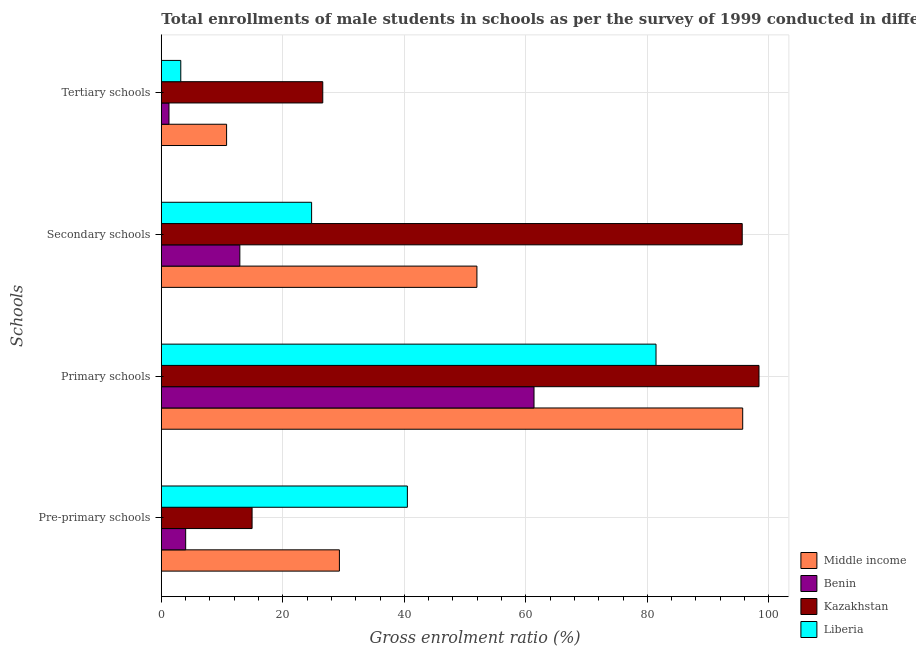How many groups of bars are there?
Give a very brief answer. 4. Are the number of bars on each tick of the Y-axis equal?
Provide a succinct answer. Yes. How many bars are there on the 1st tick from the bottom?
Your response must be concise. 4. What is the label of the 1st group of bars from the top?
Your answer should be very brief. Tertiary schools. What is the gross enrolment ratio(male) in pre-primary schools in Middle income?
Provide a succinct answer. 29.31. Across all countries, what is the maximum gross enrolment ratio(male) in primary schools?
Provide a short and direct response. 98.38. Across all countries, what is the minimum gross enrolment ratio(male) in primary schools?
Your response must be concise. 61.35. In which country was the gross enrolment ratio(male) in pre-primary schools maximum?
Your answer should be compact. Liberia. In which country was the gross enrolment ratio(male) in tertiary schools minimum?
Keep it short and to the point. Benin. What is the total gross enrolment ratio(male) in primary schools in the graph?
Your response must be concise. 336.86. What is the difference between the gross enrolment ratio(male) in pre-primary schools in Liberia and that in Benin?
Make the answer very short. 36.49. What is the difference between the gross enrolment ratio(male) in tertiary schools in Liberia and the gross enrolment ratio(male) in primary schools in Benin?
Ensure brevity in your answer.  -58.14. What is the average gross enrolment ratio(male) in primary schools per country?
Offer a very short reply. 84.21. What is the difference between the gross enrolment ratio(male) in primary schools and gross enrolment ratio(male) in secondary schools in Kazakhstan?
Make the answer very short. 2.76. What is the ratio of the gross enrolment ratio(male) in pre-primary schools in Benin to that in Kazakhstan?
Your answer should be very brief. 0.27. Is the gross enrolment ratio(male) in pre-primary schools in Benin less than that in Liberia?
Your response must be concise. Yes. What is the difference between the highest and the second highest gross enrolment ratio(male) in secondary schools?
Your answer should be very brief. 43.67. What is the difference between the highest and the lowest gross enrolment ratio(male) in tertiary schools?
Keep it short and to the point. 25.31. In how many countries, is the gross enrolment ratio(male) in primary schools greater than the average gross enrolment ratio(male) in primary schools taken over all countries?
Keep it short and to the point. 2. What does the 3rd bar from the top in Primary schools represents?
Provide a short and direct response. Benin. What does the 4th bar from the bottom in Pre-primary schools represents?
Make the answer very short. Liberia. Is it the case that in every country, the sum of the gross enrolment ratio(male) in pre-primary schools and gross enrolment ratio(male) in primary schools is greater than the gross enrolment ratio(male) in secondary schools?
Provide a short and direct response. Yes. Does the graph contain any zero values?
Your answer should be very brief. No. How many legend labels are there?
Offer a terse response. 4. What is the title of the graph?
Keep it short and to the point. Total enrollments of male students in schools as per the survey of 1999 conducted in different countries. What is the label or title of the Y-axis?
Provide a succinct answer. Schools. What is the Gross enrolment ratio (%) of Middle income in Pre-primary schools?
Your answer should be compact. 29.31. What is the Gross enrolment ratio (%) in Benin in Pre-primary schools?
Ensure brevity in your answer.  4.01. What is the Gross enrolment ratio (%) in Kazakhstan in Pre-primary schools?
Provide a short and direct response. 14.94. What is the Gross enrolment ratio (%) in Liberia in Pre-primary schools?
Your response must be concise. 40.5. What is the Gross enrolment ratio (%) in Middle income in Primary schools?
Your answer should be compact. 95.7. What is the Gross enrolment ratio (%) in Benin in Primary schools?
Give a very brief answer. 61.35. What is the Gross enrolment ratio (%) of Kazakhstan in Primary schools?
Provide a succinct answer. 98.38. What is the Gross enrolment ratio (%) of Liberia in Primary schools?
Provide a succinct answer. 81.43. What is the Gross enrolment ratio (%) in Middle income in Secondary schools?
Make the answer very short. 51.95. What is the Gross enrolment ratio (%) in Benin in Secondary schools?
Provide a short and direct response. 12.93. What is the Gross enrolment ratio (%) of Kazakhstan in Secondary schools?
Your answer should be compact. 95.62. What is the Gross enrolment ratio (%) in Liberia in Secondary schools?
Offer a terse response. 24.74. What is the Gross enrolment ratio (%) of Middle income in Tertiary schools?
Give a very brief answer. 10.74. What is the Gross enrolment ratio (%) in Benin in Tertiary schools?
Give a very brief answer. 1.26. What is the Gross enrolment ratio (%) in Kazakhstan in Tertiary schools?
Your answer should be compact. 26.58. What is the Gross enrolment ratio (%) of Liberia in Tertiary schools?
Make the answer very short. 3.2. Across all Schools, what is the maximum Gross enrolment ratio (%) in Middle income?
Offer a very short reply. 95.7. Across all Schools, what is the maximum Gross enrolment ratio (%) in Benin?
Your response must be concise. 61.35. Across all Schools, what is the maximum Gross enrolment ratio (%) in Kazakhstan?
Your response must be concise. 98.38. Across all Schools, what is the maximum Gross enrolment ratio (%) of Liberia?
Make the answer very short. 81.43. Across all Schools, what is the minimum Gross enrolment ratio (%) of Middle income?
Your response must be concise. 10.74. Across all Schools, what is the minimum Gross enrolment ratio (%) of Benin?
Provide a succinct answer. 1.26. Across all Schools, what is the minimum Gross enrolment ratio (%) in Kazakhstan?
Ensure brevity in your answer.  14.94. Across all Schools, what is the minimum Gross enrolment ratio (%) of Liberia?
Your answer should be very brief. 3.2. What is the total Gross enrolment ratio (%) of Middle income in the graph?
Provide a succinct answer. 187.71. What is the total Gross enrolment ratio (%) in Benin in the graph?
Provide a short and direct response. 79.54. What is the total Gross enrolment ratio (%) in Kazakhstan in the graph?
Your answer should be very brief. 235.52. What is the total Gross enrolment ratio (%) in Liberia in the graph?
Provide a succinct answer. 149.87. What is the difference between the Gross enrolment ratio (%) of Middle income in Pre-primary schools and that in Primary schools?
Your response must be concise. -66.39. What is the difference between the Gross enrolment ratio (%) of Benin in Pre-primary schools and that in Primary schools?
Provide a succinct answer. -57.34. What is the difference between the Gross enrolment ratio (%) in Kazakhstan in Pre-primary schools and that in Primary schools?
Make the answer very short. -83.44. What is the difference between the Gross enrolment ratio (%) of Liberia in Pre-primary schools and that in Primary schools?
Your answer should be compact. -40.93. What is the difference between the Gross enrolment ratio (%) in Middle income in Pre-primary schools and that in Secondary schools?
Offer a very short reply. -22.64. What is the difference between the Gross enrolment ratio (%) in Benin in Pre-primary schools and that in Secondary schools?
Offer a terse response. -8.92. What is the difference between the Gross enrolment ratio (%) in Kazakhstan in Pre-primary schools and that in Secondary schools?
Your response must be concise. -80.68. What is the difference between the Gross enrolment ratio (%) in Liberia in Pre-primary schools and that in Secondary schools?
Keep it short and to the point. 15.76. What is the difference between the Gross enrolment ratio (%) of Middle income in Pre-primary schools and that in Tertiary schools?
Your answer should be very brief. 18.57. What is the difference between the Gross enrolment ratio (%) of Benin in Pre-primary schools and that in Tertiary schools?
Your answer should be compact. 2.75. What is the difference between the Gross enrolment ratio (%) of Kazakhstan in Pre-primary schools and that in Tertiary schools?
Offer a terse response. -11.63. What is the difference between the Gross enrolment ratio (%) of Liberia in Pre-primary schools and that in Tertiary schools?
Keep it short and to the point. 37.3. What is the difference between the Gross enrolment ratio (%) in Middle income in Primary schools and that in Secondary schools?
Ensure brevity in your answer.  43.75. What is the difference between the Gross enrolment ratio (%) of Benin in Primary schools and that in Secondary schools?
Offer a terse response. 48.42. What is the difference between the Gross enrolment ratio (%) in Kazakhstan in Primary schools and that in Secondary schools?
Ensure brevity in your answer.  2.76. What is the difference between the Gross enrolment ratio (%) of Liberia in Primary schools and that in Secondary schools?
Give a very brief answer. 56.69. What is the difference between the Gross enrolment ratio (%) in Middle income in Primary schools and that in Tertiary schools?
Make the answer very short. 84.95. What is the difference between the Gross enrolment ratio (%) in Benin in Primary schools and that in Tertiary schools?
Give a very brief answer. 60.09. What is the difference between the Gross enrolment ratio (%) of Kazakhstan in Primary schools and that in Tertiary schools?
Your answer should be very brief. 71.81. What is the difference between the Gross enrolment ratio (%) in Liberia in Primary schools and that in Tertiary schools?
Offer a terse response. 78.23. What is the difference between the Gross enrolment ratio (%) of Middle income in Secondary schools and that in Tertiary schools?
Keep it short and to the point. 41.21. What is the difference between the Gross enrolment ratio (%) in Benin in Secondary schools and that in Tertiary schools?
Make the answer very short. 11.66. What is the difference between the Gross enrolment ratio (%) of Kazakhstan in Secondary schools and that in Tertiary schools?
Offer a very short reply. 69.05. What is the difference between the Gross enrolment ratio (%) of Liberia in Secondary schools and that in Tertiary schools?
Provide a succinct answer. 21.53. What is the difference between the Gross enrolment ratio (%) in Middle income in Pre-primary schools and the Gross enrolment ratio (%) in Benin in Primary schools?
Offer a very short reply. -32.03. What is the difference between the Gross enrolment ratio (%) of Middle income in Pre-primary schools and the Gross enrolment ratio (%) of Kazakhstan in Primary schools?
Provide a short and direct response. -69.07. What is the difference between the Gross enrolment ratio (%) in Middle income in Pre-primary schools and the Gross enrolment ratio (%) in Liberia in Primary schools?
Your answer should be very brief. -52.12. What is the difference between the Gross enrolment ratio (%) in Benin in Pre-primary schools and the Gross enrolment ratio (%) in Kazakhstan in Primary schools?
Provide a succinct answer. -94.37. What is the difference between the Gross enrolment ratio (%) of Benin in Pre-primary schools and the Gross enrolment ratio (%) of Liberia in Primary schools?
Your answer should be very brief. -77.42. What is the difference between the Gross enrolment ratio (%) of Kazakhstan in Pre-primary schools and the Gross enrolment ratio (%) of Liberia in Primary schools?
Provide a short and direct response. -66.49. What is the difference between the Gross enrolment ratio (%) of Middle income in Pre-primary schools and the Gross enrolment ratio (%) of Benin in Secondary schools?
Make the answer very short. 16.39. What is the difference between the Gross enrolment ratio (%) of Middle income in Pre-primary schools and the Gross enrolment ratio (%) of Kazakhstan in Secondary schools?
Offer a terse response. -66.31. What is the difference between the Gross enrolment ratio (%) in Middle income in Pre-primary schools and the Gross enrolment ratio (%) in Liberia in Secondary schools?
Offer a very short reply. 4.58. What is the difference between the Gross enrolment ratio (%) in Benin in Pre-primary schools and the Gross enrolment ratio (%) in Kazakhstan in Secondary schools?
Provide a succinct answer. -91.61. What is the difference between the Gross enrolment ratio (%) in Benin in Pre-primary schools and the Gross enrolment ratio (%) in Liberia in Secondary schools?
Your answer should be very brief. -20.73. What is the difference between the Gross enrolment ratio (%) in Kazakhstan in Pre-primary schools and the Gross enrolment ratio (%) in Liberia in Secondary schools?
Give a very brief answer. -9.8. What is the difference between the Gross enrolment ratio (%) of Middle income in Pre-primary schools and the Gross enrolment ratio (%) of Benin in Tertiary schools?
Your answer should be very brief. 28.05. What is the difference between the Gross enrolment ratio (%) in Middle income in Pre-primary schools and the Gross enrolment ratio (%) in Kazakhstan in Tertiary schools?
Keep it short and to the point. 2.74. What is the difference between the Gross enrolment ratio (%) of Middle income in Pre-primary schools and the Gross enrolment ratio (%) of Liberia in Tertiary schools?
Ensure brevity in your answer.  26.11. What is the difference between the Gross enrolment ratio (%) in Benin in Pre-primary schools and the Gross enrolment ratio (%) in Kazakhstan in Tertiary schools?
Provide a succinct answer. -22.57. What is the difference between the Gross enrolment ratio (%) of Benin in Pre-primary schools and the Gross enrolment ratio (%) of Liberia in Tertiary schools?
Provide a succinct answer. 0.8. What is the difference between the Gross enrolment ratio (%) of Kazakhstan in Pre-primary schools and the Gross enrolment ratio (%) of Liberia in Tertiary schools?
Offer a very short reply. 11.74. What is the difference between the Gross enrolment ratio (%) of Middle income in Primary schools and the Gross enrolment ratio (%) of Benin in Secondary schools?
Your response must be concise. 82.77. What is the difference between the Gross enrolment ratio (%) of Middle income in Primary schools and the Gross enrolment ratio (%) of Kazakhstan in Secondary schools?
Keep it short and to the point. 0.08. What is the difference between the Gross enrolment ratio (%) in Middle income in Primary schools and the Gross enrolment ratio (%) in Liberia in Secondary schools?
Offer a very short reply. 70.96. What is the difference between the Gross enrolment ratio (%) of Benin in Primary schools and the Gross enrolment ratio (%) of Kazakhstan in Secondary schools?
Keep it short and to the point. -34.27. What is the difference between the Gross enrolment ratio (%) of Benin in Primary schools and the Gross enrolment ratio (%) of Liberia in Secondary schools?
Provide a succinct answer. 36.61. What is the difference between the Gross enrolment ratio (%) of Kazakhstan in Primary schools and the Gross enrolment ratio (%) of Liberia in Secondary schools?
Provide a short and direct response. 73.64. What is the difference between the Gross enrolment ratio (%) in Middle income in Primary schools and the Gross enrolment ratio (%) in Benin in Tertiary schools?
Ensure brevity in your answer.  94.44. What is the difference between the Gross enrolment ratio (%) of Middle income in Primary schools and the Gross enrolment ratio (%) of Kazakhstan in Tertiary schools?
Keep it short and to the point. 69.12. What is the difference between the Gross enrolment ratio (%) of Middle income in Primary schools and the Gross enrolment ratio (%) of Liberia in Tertiary schools?
Make the answer very short. 92.5. What is the difference between the Gross enrolment ratio (%) in Benin in Primary schools and the Gross enrolment ratio (%) in Kazakhstan in Tertiary schools?
Your answer should be compact. 34.77. What is the difference between the Gross enrolment ratio (%) of Benin in Primary schools and the Gross enrolment ratio (%) of Liberia in Tertiary schools?
Your answer should be compact. 58.14. What is the difference between the Gross enrolment ratio (%) in Kazakhstan in Primary schools and the Gross enrolment ratio (%) in Liberia in Tertiary schools?
Keep it short and to the point. 95.18. What is the difference between the Gross enrolment ratio (%) of Middle income in Secondary schools and the Gross enrolment ratio (%) of Benin in Tertiary schools?
Offer a very short reply. 50.69. What is the difference between the Gross enrolment ratio (%) of Middle income in Secondary schools and the Gross enrolment ratio (%) of Kazakhstan in Tertiary schools?
Provide a succinct answer. 25.38. What is the difference between the Gross enrolment ratio (%) in Middle income in Secondary schools and the Gross enrolment ratio (%) in Liberia in Tertiary schools?
Your response must be concise. 48.75. What is the difference between the Gross enrolment ratio (%) of Benin in Secondary schools and the Gross enrolment ratio (%) of Kazakhstan in Tertiary schools?
Keep it short and to the point. -13.65. What is the difference between the Gross enrolment ratio (%) in Benin in Secondary schools and the Gross enrolment ratio (%) in Liberia in Tertiary schools?
Your response must be concise. 9.72. What is the difference between the Gross enrolment ratio (%) of Kazakhstan in Secondary schools and the Gross enrolment ratio (%) of Liberia in Tertiary schools?
Your answer should be compact. 92.42. What is the average Gross enrolment ratio (%) of Middle income per Schools?
Ensure brevity in your answer.  46.93. What is the average Gross enrolment ratio (%) in Benin per Schools?
Your answer should be very brief. 19.89. What is the average Gross enrolment ratio (%) of Kazakhstan per Schools?
Give a very brief answer. 58.88. What is the average Gross enrolment ratio (%) of Liberia per Schools?
Provide a succinct answer. 37.47. What is the difference between the Gross enrolment ratio (%) of Middle income and Gross enrolment ratio (%) of Benin in Pre-primary schools?
Your answer should be compact. 25.3. What is the difference between the Gross enrolment ratio (%) in Middle income and Gross enrolment ratio (%) in Kazakhstan in Pre-primary schools?
Give a very brief answer. 14.37. What is the difference between the Gross enrolment ratio (%) of Middle income and Gross enrolment ratio (%) of Liberia in Pre-primary schools?
Provide a short and direct response. -11.19. What is the difference between the Gross enrolment ratio (%) in Benin and Gross enrolment ratio (%) in Kazakhstan in Pre-primary schools?
Keep it short and to the point. -10.93. What is the difference between the Gross enrolment ratio (%) of Benin and Gross enrolment ratio (%) of Liberia in Pre-primary schools?
Your answer should be very brief. -36.49. What is the difference between the Gross enrolment ratio (%) of Kazakhstan and Gross enrolment ratio (%) of Liberia in Pre-primary schools?
Offer a terse response. -25.56. What is the difference between the Gross enrolment ratio (%) of Middle income and Gross enrolment ratio (%) of Benin in Primary schools?
Provide a short and direct response. 34.35. What is the difference between the Gross enrolment ratio (%) of Middle income and Gross enrolment ratio (%) of Kazakhstan in Primary schools?
Offer a terse response. -2.68. What is the difference between the Gross enrolment ratio (%) in Middle income and Gross enrolment ratio (%) in Liberia in Primary schools?
Offer a very short reply. 14.27. What is the difference between the Gross enrolment ratio (%) in Benin and Gross enrolment ratio (%) in Kazakhstan in Primary schools?
Make the answer very short. -37.03. What is the difference between the Gross enrolment ratio (%) in Benin and Gross enrolment ratio (%) in Liberia in Primary schools?
Offer a terse response. -20.08. What is the difference between the Gross enrolment ratio (%) of Kazakhstan and Gross enrolment ratio (%) of Liberia in Primary schools?
Make the answer very short. 16.95. What is the difference between the Gross enrolment ratio (%) of Middle income and Gross enrolment ratio (%) of Benin in Secondary schools?
Keep it short and to the point. 39.02. What is the difference between the Gross enrolment ratio (%) of Middle income and Gross enrolment ratio (%) of Kazakhstan in Secondary schools?
Your answer should be compact. -43.67. What is the difference between the Gross enrolment ratio (%) of Middle income and Gross enrolment ratio (%) of Liberia in Secondary schools?
Ensure brevity in your answer.  27.21. What is the difference between the Gross enrolment ratio (%) of Benin and Gross enrolment ratio (%) of Kazakhstan in Secondary schools?
Keep it short and to the point. -82.69. What is the difference between the Gross enrolment ratio (%) in Benin and Gross enrolment ratio (%) in Liberia in Secondary schools?
Your response must be concise. -11.81. What is the difference between the Gross enrolment ratio (%) in Kazakhstan and Gross enrolment ratio (%) in Liberia in Secondary schools?
Keep it short and to the point. 70.88. What is the difference between the Gross enrolment ratio (%) in Middle income and Gross enrolment ratio (%) in Benin in Tertiary schools?
Offer a very short reply. 9.48. What is the difference between the Gross enrolment ratio (%) in Middle income and Gross enrolment ratio (%) in Kazakhstan in Tertiary schools?
Keep it short and to the point. -15.83. What is the difference between the Gross enrolment ratio (%) of Middle income and Gross enrolment ratio (%) of Liberia in Tertiary schools?
Offer a terse response. 7.54. What is the difference between the Gross enrolment ratio (%) of Benin and Gross enrolment ratio (%) of Kazakhstan in Tertiary schools?
Provide a short and direct response. -25.31. What is the difference between the Gross enrolment ratio (%) of Benin and Gross enrolment ratio (%) of Liberia in Tertiary schools?
Offer a terse response. -1.94. What is the difference between the Gross enrolment ratio (%) in Kazakhstan and Gross enrolment ratio (%) in Liberia in Tertiary schools?
Give a very brief answer. 23.37. What is the ratio of the Gross enrolment ratio (%) in Middle income in Pre-primary schools to that in Primary schools?
Your answer should be very brief. 0.31. What is the ratio of the Gross enrolment ratio (%) in Benin in Pre-primary schools to that in Primary schools?
Keep it short and to the point. 0.07. What is the ratio of the Gross enrolment ratio (%) of Kazakhstan in Pre-primary schools to that in Primary schools?
Your response must be concise. 0.15. What is the ratio of the Gross enrolment ratio (%) of Liberia in Pre-primary schools to that in Primary schools?
Your answer should be compact. 0.5. What is the ratio of the Gross enrolment ratio (%) in Middle income in Pre-primary schools to that in Secondary schools?
Keep it short and to the point. 0.56. What is the ratio of the Gross enrolment ratio (%) of Benin in Pre-primary schools to that in Secondary schools?
Provide a short and direct response. 0.31. What is the ratio of the Gross enrolment ratio (%) of Kazakhstan in Pre-primary schools to that in Secondary schools?
Provide a succinct answer. 0.16. What is the ratio of the Gross enrolment ratio (%) of Liberia in Pre-primary schools to that in Secondary schools?
Provide a succinct answer. 1.64. What is the ratio of the Gross enrolment ratio (%) of Middle income in Pre-primary schools to that in Tertiary schools?
Offer a very short reply. 2.73. What is the ratio of the Gross enrolment ratio (%) in Benin in Pre-primary schools to that in Tertiary schools?
Provide a succinct answer. 3.18. What is the ratio of the Gross enrolment ratio (%) in Kazakhstan in Pre-primary schools to that in Tertiary schools?
Offer a terse response. 0.56. What is the ratio of the Gross enrolment ratio (%) of Liberia in Pre-primary schools to that in Tertiary schools?
Provide a succinct answer. 12.64. What is the ratio of the Gross enrolment ratio (%) of Middle income in Primary schools to that in Secondary schools?
Your response must be concise. 1.84. What is the ratio of the Gross enrolment ratio (%) of Benin in Primary schools to that in Secondary schools?
Offer a terse response. 4.75. What is the ratio of the Gross enrolment ratio (%) in Kazakhstan in Primary schools to that in Secondary schools?
Offer a terse response. 1.03. What is the ratio of the Gross enrolment ratio (%) of Liberia in Primary schools to that in Secondary schools?
Keep it short and to the point. 3.29. What is the ratio of the Gross enrolment ratio (%) of Middle income in Primary schools to that in Tertiary schools?
Ensure brevity in your answer.  8.91. What is the ratio of the Gross enrolment ratio (%) in Benin in Primary schools to that in Tertiary schools?
Your answer should be very brief. 48.6. What is the ratio of the Gross enrolment ratio (%) of Kazakhstan in Primary schools to that in Tertiary schools?
Provide a succinct answer. 3.7. What is the ratio of the Gross enrolment ratio (%) in Liberia in Primary schools to that in Tertiary schools?
Offer a very short reply. 25.42. What is the ratio of the Gross enrolment ratio (%) of Middle income in Secondary schools to that in Tertiary schools?
Give a very brief answer. 4.84. What is the ratio of the Gross enrolment ratio (%) in Benin in Secondary schools to that in Tertiary schools?
Your answer should be very brief. 10.24. What is the ratio of the Gross enrolment ratio (%) in Kazakhstan in Secondary schools to that in Tertiary schools?
Provide a short and direct response. 3.6. What is the ratio of the Gross enrolment ratio (%) of Liberia in Secondary schools to that in Tertiary schools?
Your response must be concise. 7.72. What is the difference between the highest and the second highest Gross enrolment ratio (%) in Middle income?
Provide a succinct answer. 43.75. What is the difference between the highest and the second highest Gross enrolment ratio (%) in Benin?
Your response must be concise. 48.42. What is the difference between the highest and the second highest Gross enrolment ratio (%) in Kazakhstan?
Give a very brief answer. 2.76. What is the difference between the highest and the second highest Gross enrolment ratio (%) of Liberia?
Give a very brief answer. 40.93. What is the difference between the highest and the lowest Gross enrolment ratio (%) in Middle income?
Make the answer very short. 84.95. What is the difference between the highest and the lowest Gross enrolment ratio (%) of Benin?
Make the answer very short. 60.09. What is the difference between the highest and the lowest Gross enrolment ratio (%) in Kazakhstan?
Keep it short and to the point. 83.44. What is the difference between the highest and the lowest Gross enrolment ratio (%) in Liberia?
Your answer should be compact. 78.23. 